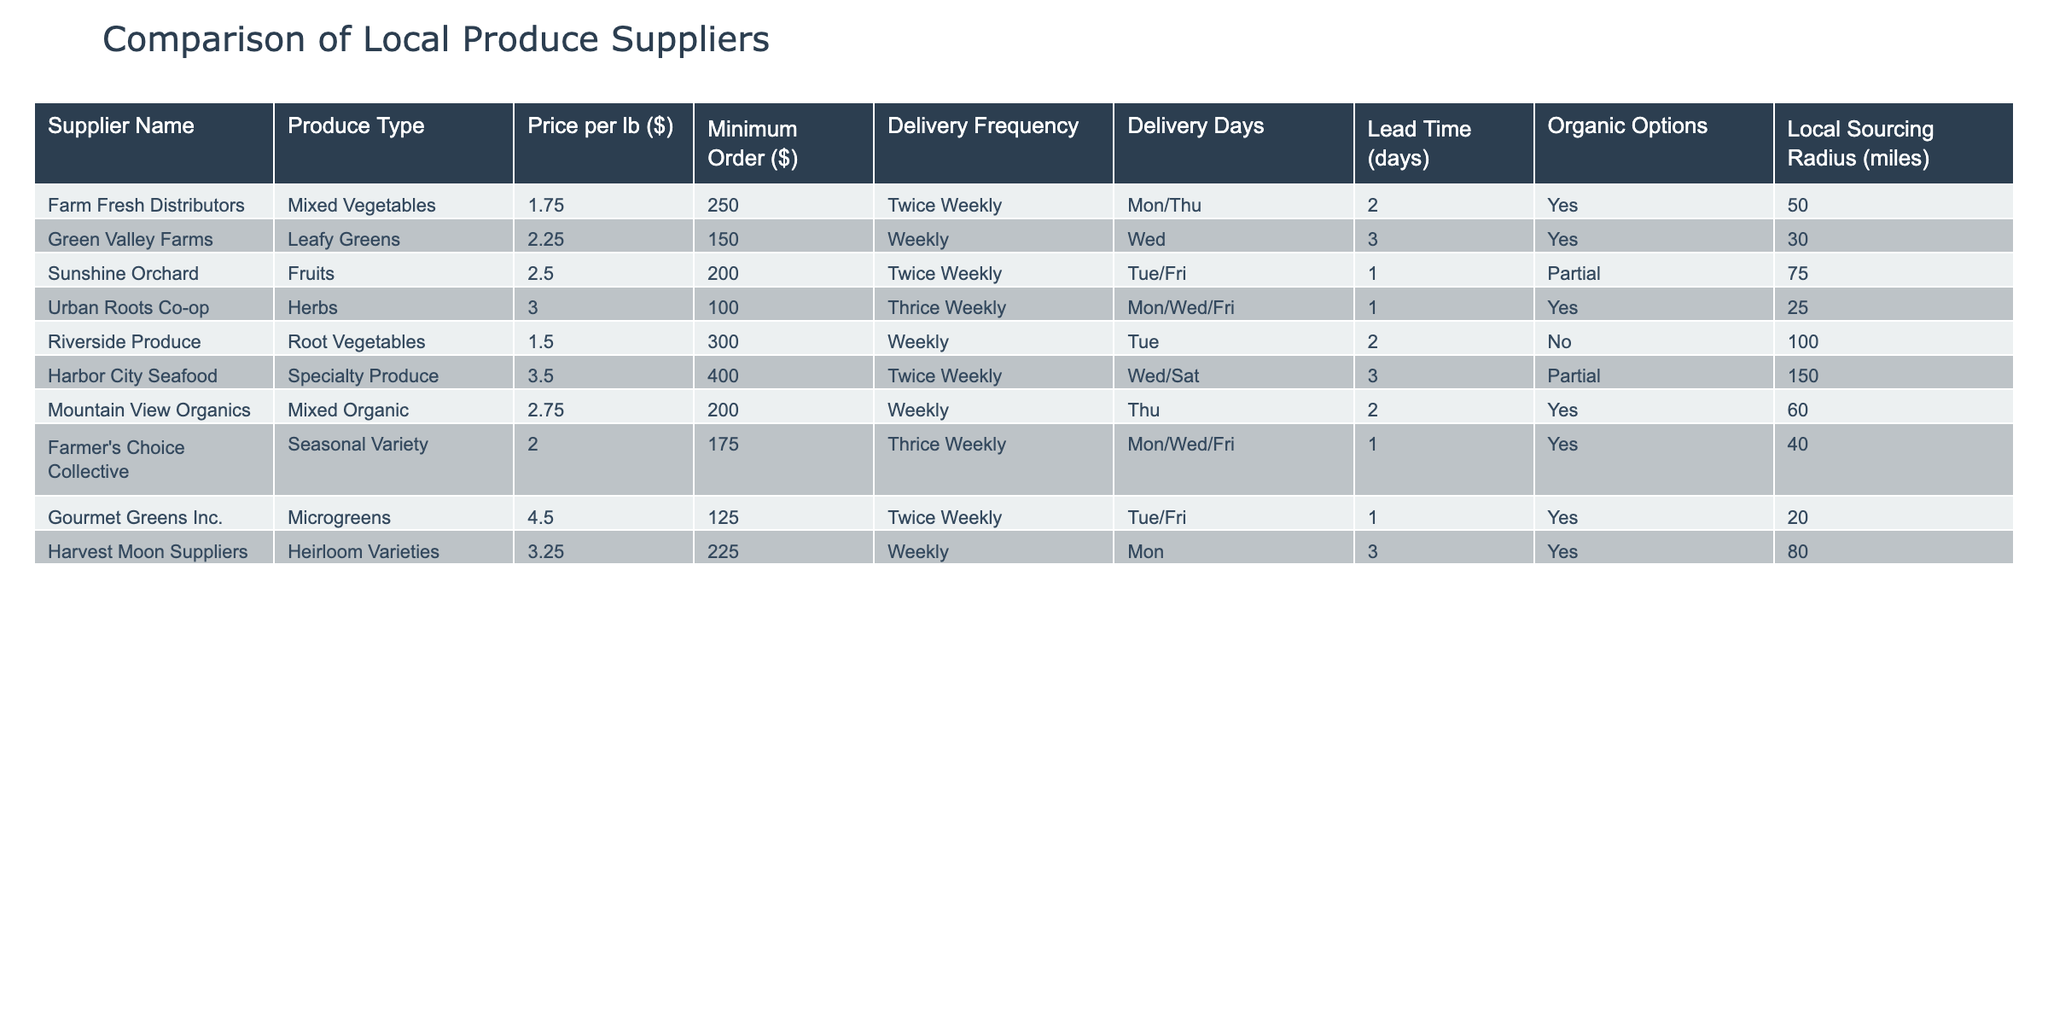What is the price per lb of Mixed Vegetables from Farm Fresh Distributors? The price for Mixed Vegetables is listed under the column "Price per lb ($)" for Farm Fresh Distributors, which provides a direct answer.
Answer: 1.75 Which supplier offers the lowest minimum order amount? By reviewing the "Minimum Order ($)" column, Riverside Produce has the lowest value at 300, while others vary.
Answer: 100 How many suppliers provide organic options? We can count the rows where "Organic Options" is marked as "Yes" in the table. Farm Fresh Distributors, Green Valley Farms, Urban Roots Co-op, Mountain View Organics, Farmer's Choice Collective, and Gourmet Greens Inc. all offer organic options, totaling six suppliers.
Answer: 6 What is the average price per lb for suppliers that deliver twice a week? The suppliers that deliver twice a week are Farm Fresh Distributors, Sunshine Orchard, and Harbor City Seafood. Their prices are 1.75, 2.50, and 3.50 respectively. The average is calculated as (1.75 + 2.50 + 3.50) / 3 = 2.25.
Answer: 2.25 Is there a supplier that sources within a radius of 20 miles and offers organic produce? Checking the "Local Sourcing Radius (miles)" and "Organic Options," the only supplier that fits this criterion is Gourmet Greens Inc., which offers organic microgreens sourced within 20 miles.
Answer: Yes How many suppliers deliver on Wednesdays? We find the "Delivery Days" column and look for providers that include "Wed," which are Green Valley Farms, Urban Roots Co-op, Farmer's Choice Collective, and Harbor City Seafood, summing up to four suppliers.
Answer: 4 Which type of produce has the highest price per lb? From the "Produce Type" and "Price per lb ($)" sections, the highest price is for Microgreens at 4.50 per lb from Gourmet Greens Inc.
Answer: Microgreens What is the total cost of the minimum orders for all suppliers that provide mixed organic produce? Only Mountain View Organics provides "Mixed Organic" produce, with a minimum order amount of 200. Since there is only one supplier in this category, the total is simply the minimum order amount itself.
Answer: 200 